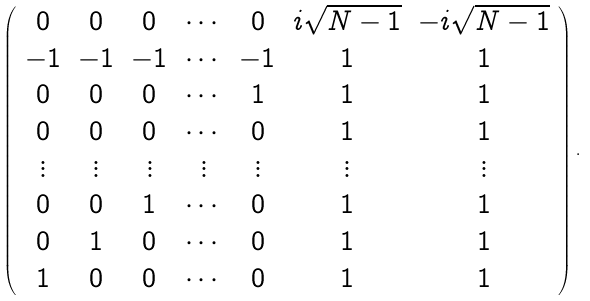<formula> <loc_0><loc_0><loc_500><loc_500>\left ( \begin{array} { c c c c c c c } 0 & 0 & 0 & \cdots & 0 & i \sqrt { N - 1 } & - i \sqrt { N - 1 } \\ - 1 & - 1 & - 1 & \cdots & - 1 & 1 & 1 \\ 0 & 0 & 0 & \cdots & 1 & 1 & 1 \\ 0 & 0 & 0 & \cdots & 0 & 1 & 1 \\ \vdots & \vdots & \vdots & \vdots & \vdots & \vdots & \vdots \\ 0 & 0 & 1 & \cdots & 0 & 1 & 1 \\ 0 & 1 & 0 & \cdots & 0 & 1 & 1 \\ 1 & 0 & 0 & \cdots & 0 & 1 & 1 \end{array} \right ) .</formula> 